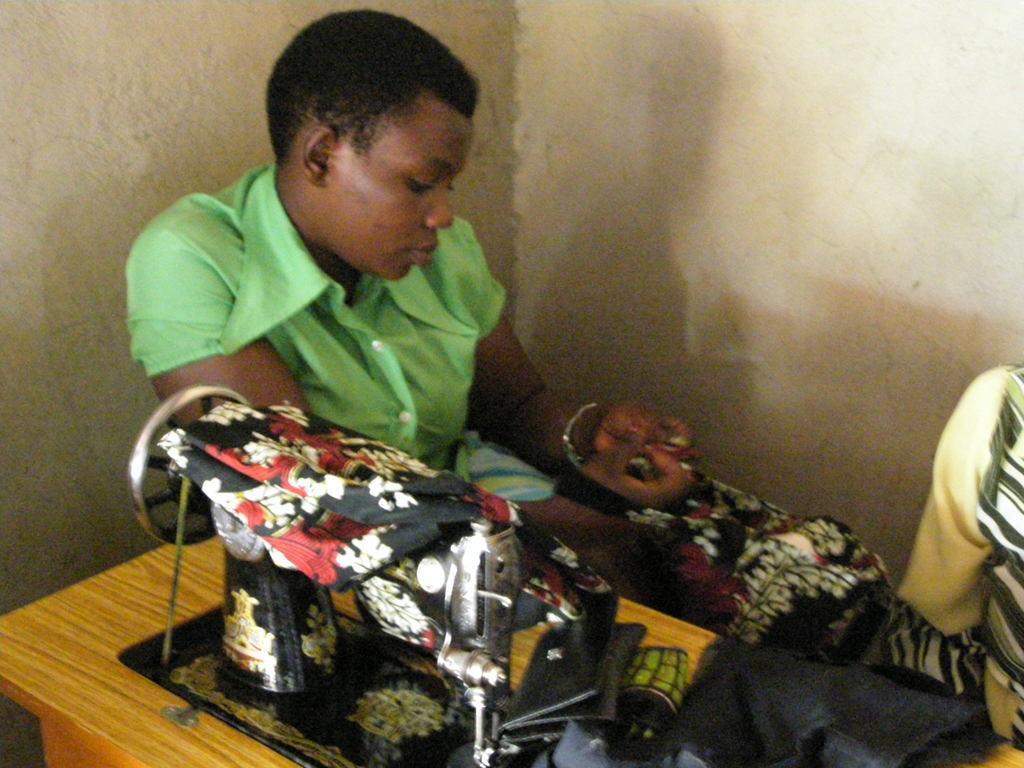Describe this image in one or two sentences. In the center of the image there is a woman sitting at the table. On the table we can see stitch machine and clothes. In the background there is wall. 